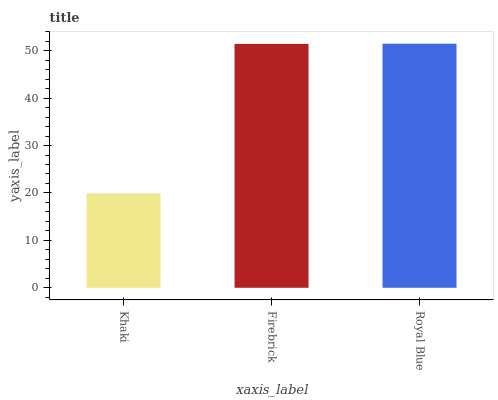Is Khaki the minimum?
Answer yes or no. Yes. Is Royal Blue the maximum?
Answer yes or no. Yes. Is Firebrick the minimum?
Answer yes or no. No. Is Firebrick the maximum?
Answer yes or no. No. Is Firebrick greater than Khaki?
Answer yes or no. Yes. Is Khaki less than Firebrick?
Answer yes or no. Yes. Is Khaki greater than Firebrick?
Answer yes or no. No. Is Firebrick less than Khaki?
Answer yes or no. No. Is Firebrick the high median?
Answer yes or no. Yes. Is Firebrick the low median?
Answer yes or no. Yes. Is Royal Blue the high median?
Answer yes or no. No. Is Khaki the low median?
Answer yes or no. No. 